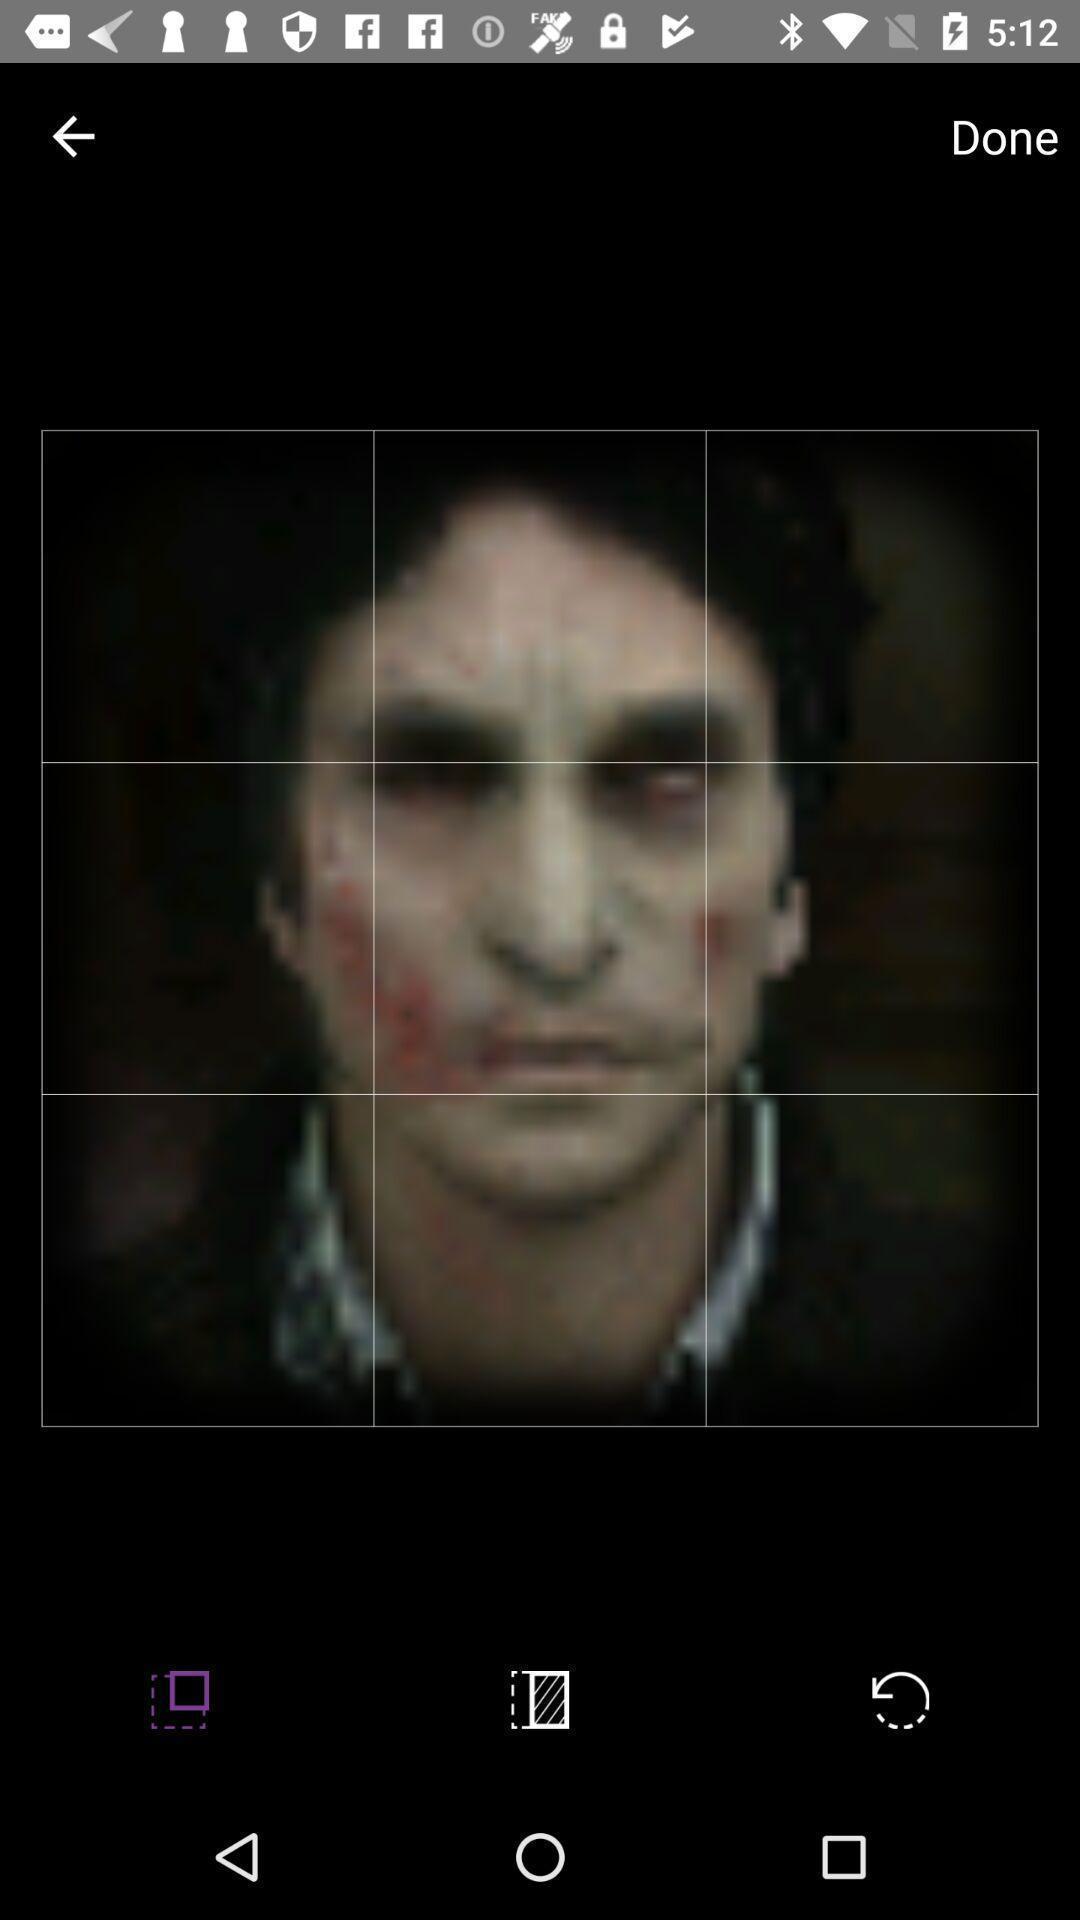Tell me what you see in this picture. Page showing profile image of a dating app. 